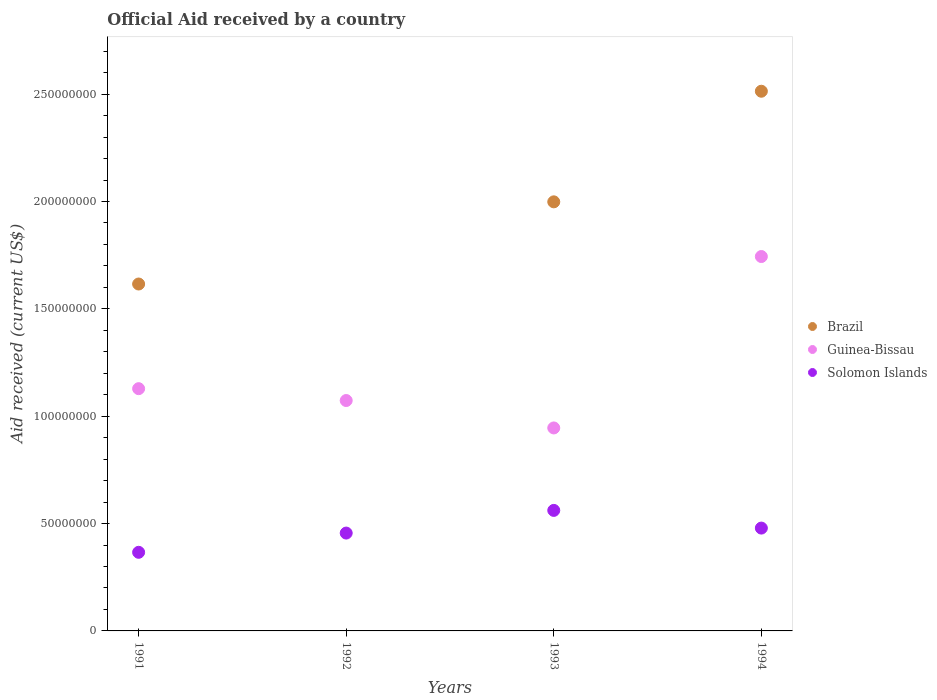Is the number of dotlines equal to the number of legend labels?
Your answer should be very brief. No. What is the net official aid received in Solomon Islands in 1992?
Your response must be concise. 4.56e+07. Across all years, what is the maximum net official aid received in Guinea-Bissau?
Provide a short and direct response. 1.74e+08. Across all years, what is the minimum net official aid received in Guinea-Bissau?
Your answer should be very brief. 9.45e+07. In which year was the net official aid received in Brazil maximum?
Offer a terse response. 1994. What is the total net official aid received in Brazil in the graph?
Give a very brief answer. 6.13e+08. What is the difference between the net official aid received in Guinea-Bissau in 1991 and that in 1993?
Your response must be concise. 1.83e+07. What is the difference between the net official aid received in Guinea-Bissau in 1993 and the net official aid received in Brazil in 1991?
Make the answer very short. -6.70e+07. What is the average net official aid received in Brazil per year?
Provide a succinct answer. 1.53e+08. In the year 1991, what is the difference between the net official aid received in Guinea-Bissau and net official aid received in Brazil?
Offer a very short reply. -4.87e+07. What is the ratio of the net official aid received in Guinea-Bissau in 1992 to that in 1994?
Provide a succinct answer. 0.62. Is the net official aid received in Solomon Islands in 1991 less than that in 1994?
Offer a very short reply. Yes. Is the difference between the net official aid received in Guinea-Bissau in 1991 and 1994 greater than the difference between the net official aid received in Brazil in 1991 and 1994?
Ensure brevity in your answer.  Yes. What is the difference between the highest and the second highest net official aid received in Solomon Islands?
Offer a very short reply. 8.24e+06. What is the difference between the highest and the lowest net official aid received in Guinea-Bissau?
Ensure brevity in your answer.  7.98e+07. In how many years, is the net official aid received in Guinea-Bissau greater than the average net official aid received in Guinea-Bissau taken over all years?
Offer a terse response. 1. Is the sum of the net official aid received in Solomon Islands in 1993 and 1994 greater than the maximum net official aid received in Guinea-Bissau across all years?
Offer a very short reply. No. Is it the case that in every year, the sum of the net official aid received in Solomon Islands and net official aid received in Brazil  is greater than the net official aid received in Guinea-Bissau?
Your answer should be very brief. No. Does the net official aid received in Solomon Islands monotonically increase over the years?
Provide a short and direct response. No. How many dotlines are there?
Keep it short and to the point. 3. How many years are there in the graph?
Ensure brevity in your answer.  4. What is the difference between two consecutive major ticks on the Y-axis?
Offer a very short reply. 5.00e+07. Are the values on the major ticks of Y-axis written in scientific E-notation?
Provide a succinct answer. No. Does the graph contain any zero values?
Make the answer very short. Yes. How many legend labels are there?
Provide a short and direct response. 3. How are the legend labels stacked?
Provide a short and direct response. Vertical. What is the title of the graph?
Your response must be concise. Official Aid received by a country. What is the label or title of the Y-axis?
Keep it short and to the point. Aid received (current US$). What is the Aid received (current US$) in Brazil in 1991?
Offer a very short reply. 1.62e+08. What is the Aid received (current US$) of Guinea-Bissau in 1991?
Your response must be concise. 1.13e+08. What is the Aid received (current US$) in Solomon Islands in 1991?
Provide a short and direct response. 3.66e+07. What is the Aid received (current US$) of Guinea-Bissau in 1992?
Your answer should be very brief. 1.07e+08. What is the Aid received (current US$) in Solomon Islands in 1992?
Your response must be concise. 4.56e+07. What is the Aid received (current US$) in Brazil in 1993?
Make the answer very short. 2.00e+08. What is the Aid received (current US$) of Guinea-Bissau in 1993?
Offer a very short reply. 9.45e+07. What is the Aid received (current US$) in Solomon Islands in 1993?
Ensure brevity in your answer.  5.61e+07. What is the Aid received (current US$) of Brazil in 1994?
Give a very brief answer. 2.51e+08. What is the Aid received (current US$) of Guinea-Bissau in 1994?
Make the answer very short. 1.74e+08. What is the Aid received (current US$) of Solomon Islands in 1994?
Your answer should be compact. 4.79e+07. Across all years, what is the maximum Aid received (current US$) in Brazil?
Offer a terse response. 2.51e+08. Across all years, what is the maximum Aid received (current US$) of Guinea-Bissau?
Ensure brevity in your answer.  1.74e+08. Across all years, what is the maximum Aid received (current US$) in Solomon Islands?
Provide a succinct answer. 5.61e+07. Across all years, what is the minimum Aid received (current US$) in Brazil?
Make the answer very short. 0. Across all years, what is the minimum Aid received (current US$) in Guinea-Bissau?
Offer a very short reply. 9.45e+07. Across all years, what is the minimum Aid received (current US$) in Solomon Islands?
Give a very brief answer. 3.66e+07. What is the total Aid received (current US$) of Brazil in the graph?
Your answer should be compact. 6.13e+08. What is the total Aid received (current US$) of Guinea-Bissau in the graph?
Give a very brief answer. 4.89e+08. What is the total Aid received (current US$) in Solomon Islands in the graph?
Provide a short and direct response. 1.86e+08. What is the difference between the Aid received (current US$) of Guinea-Bissau in 1991 and that in 1992?
Your response must be concise. 5.52e+06. What is the difference between the Aid received (current US$) of Solomon Islands in 1991 and that in 1992?
Your answer should be very brief. -8.96e+06. What is the difference between the Aid received (current US$) in Brazil in 1991 and that in 1993?
Offer a very short reply. -3.83e+07. What is the difference between the Aid received (current US$) in Guinea-Bissau in 1991 and that in 1993?
Your answer should be compact. 1.83e+07. What is the difference between the Aid received (current US$) of Solomon Islands in 1991 and that in 1993?
Give a very brief answer. -1.95e+07. What is the difference between the Aid received (current US$) of Brazil in 1991 and that in 1994?
Your answer should be compact. -8.98e+07. What is the difference between the Aid received (current US$) of Guinea-Bissau in 1991 and that in 1994?
Provide a succinct answer. -6.15e+07. What is the difference between the Aid received (current US$) in Solomon Islands in 1991 and that in 1994?
Offer a very short reply. -1.13e+07. What is the difference between the Aid received (current US$) of Guinea-Bissau in 1992 and that in 1993?
Ensure brevity in your answer.  1.28e+07. What is the difference between the Aid received (current US$) of Solomon Islands in 1992 and that in 1993?
Provide a short and direct response. -1.06e+07. What is the difference between the Aid received (current US$) of Guinea-Bissau in 1992 and that in 1994?
Offer a very short reply. -6.71e+07. What is the difference between the Aid received (current US$) in Solomon Islands in 1992 and that in 1994?
Make the answer very short. -2.32e+06. What is the difference between the Aid received (current US$) of Brazil in 1993 and that in 1994?
Your answer should be very brief. -5.15e+07. What is the difference between the Aid received (current US$) in Guinea-Bissau in 1993 and that in 1994?
Keep it short and to the point. -7.98e+07. What is the difference between the Aid received (current US$) in Solomon Islands in 1993 and that in 1994?
Keep it short and to the point. 8.24e+06. What is the difference between the Aid received (current US$) of Brazil in 1991 and the Aid received (current US$) of Guinea-Bissau in 1992?
Provide a short and direct response. 5.43e+07. What is the difference between the Aid received (current US$) in Brazil in 1991 and the Aid received (current US$) in Solomon Islands in 1992?
Offer a terse response. 1.16e+08. What is the difference between the Aid received (current US$) of Guinea-Bissau in 1991 and the Aid received (current US$) of Solomon Islands in 1992?
Offer a very short reply. 6.72e+07. What is the difference between the Aid received (current US$) in Brazil in 1991 and the Aid received (current US$) in Guinea-Bissau in 1993?
Ensure brevity in your answer.  6.70e+07. What is the difference between the Aid received (current US$) in Brazil in 1991 and the Aid received (current US$) in Solomon Islands in 1993?
Your response must be concise. 1.05e+08. What is the difference between the Aid received (current US$) of Guinea-Bissau in 1991 and the Aid received (current US$) of Solomon Islands in 1993?
Keep it short and to the point. 5.67e+07. What is the difference between the Aid received (current US$) in Brazil in 1991 and the Aid received (current US$) in Guinea-Bissau in 1994?
Provide a succinct answer. -1.28e+07. What is the difference between the Aid received (current US$) in Brazil in 1991 and the Aid received (current US$) in Solomon Islands in 1994?
Ensure brevity in your answer.  1.14e+08. What is the difference between the Aid received (current US$) of Guinea-Bissau in 1991 and the Aid received (current US$) of Solomon Islands in 1994?
Give a very brief answer. 6.49e+07. What is the difference between the Aid received (current US$) of Guinea-Bissau in 1992 and the Aid received (current US$) of Solomon Islands in 1993?
Ensure brevity in your answer.  5.12e+07. What is the difference between the Aid received (current US$) in Guinea-Bissau in 1992 and the Aid received (current US$) in Solomon Islands in 1994?
Your response must be concise. 5.94e+07. What is the difference between the Aid received (current US$) in Brazil in 1993 and the Aid received (current US$) in Guinea-Bissau in 1994?
Provide a succinct answer. 2.55e+07. What is the difference between the Aid received (current US$) in Brazil in 1993 and the Aid received (current US$) in Solomon Islands in 1994?
Your answer should be very brief. 1.52e+08. What is the difference between the Aid received (current US$) of Guinea-Bissau in 1993 and the Aid received (current US$) of Solomon Islands in 1994?
Ensure brevity in your answer.  4.66e+07. What is the average Aid received (current US$) of Brazil per year?
Offer a very short reply. 1.53e+08. What is the average Aid received (current US$) of Guinea-Bissau per year?
Offer a terse response. 1.22e+08. What is the average Aid received (current US$) in Solomon Islands per year?
Offer a very short reply. 4.66e+07. In the year 1991, what is the difference between the Aid received (current US$) of Brazil and Aid received (current US$) of Guinea-Bissau?
Keep it short and to the point. 4.87e+07. In the year 1991, what is the difference between the Aid received (current US$) of Brazil and Aid received (current US$) of Solomon Islands?
Ensure brevity in your answer.  1.25e+08. In the year 1991, what is the difference between the Aid received (current US$) of Guinea-Bissau and Aid received (current US$) of Solomon Islands?
Your answer should be compact. 7.62e+07. In the year 1992, what is the difference between the Aid received (current US$) of Guinea-Bissau and Aid received (current US$) of Solomon Islands?
Your response must be concise. 6.17e+07. In the year 1993, what is the difference between the Aid received (current US$) of Brazil and Aid received (current US$) of Guinea-Bissau?
Offer a terse response. 1.05e+08. In the year 1993, what is the difference between the Aid received (current US$) of Brazil and Aid received (current US$) of Solomon Islands?
Provide a short and direct response. 1.44e+08. In the year 1993, what is the difference between the Aid received (current US$) of Guinea-Bissau and Aid received (current US$) of Solomon Islands?
Keep it short and to the point. 3.84e+07. In the year 1994, what is the difference between the Aid received (current US$) in Brazil and Aid received (current US$) in Guinea-Bissau?
Make the answer very short. 7.70e+07. In the year 1994, what is the difference between the Aid received (current US$) in Brazil and Aid received (current US$) in Solomon Islands?
Provide a succinct answer. 2.03e+08. In the year 1994, what is the difference between the Aid received (current US$) of Guinea-Bissau and Aid received (current US$) of Solomon Islands?
Provide a short and direct response. 1.26e+08. What is the ratio of the Aid received (current US$) in Guinea-Bissau in 1991 to that in 1992?
Offer a terse response. 1.05. What is the ratio of the Aid received (current US$) in Solomon Islands in 1991 to that in 1992?
Provide a succinct answer. 0.8. What is the ratio of the Aid received (current US$) in Brazil in 1991 to that in 1993?
Provide a succinct answer. 0.81. What is the ratio of the Aid received (current US$) in Guinea-Bissau in 1991 to that in 1993?
Keep it short and to the point. 1.19. What is the ratio of the Aid received (current US$) in Solomon Islands in 1991 to that in 1993?
Keep it short and to the point. 0.65. What is the ratio of the Aid received (current US$) in Brazil in 1991 to that in 1994?
Make the answer very short. 0.64. What is the ratio of the Aid received (current US$) of Guinea-Bissau in 1991 to that in 1994?
Give a very brief answer. 0.65. What is the ratio of the Aid received (current US$) of Solomon Islands in 1991 to that in 1994?
Give a very brief answer. 0.76. What is the ratio of the Aid received (current US$) in Guinea-Bissau in 1992 to that in 1993?
Your response must be concise. 1.14. What is the ratio of the Aid received (current US$) in Solomon Islands in 1992 to that in 1993?
Your answer should be very brief. 0.81. What is the ratio of the Aid received (current US$) of Guinea-Bissau in 1992 to that in 1994?
Provide a succinct answer. 0.62. What is the ratio of the Aid received (current US$) of Solomon Islands in 1992 to that in 1994?
Ensure brevity in your answer.  0.95. What is the ratio of the Aid received (current US$) in Brazil in 1993 to that in 1994?
Give a very brief answer. 0.8. What is the ratio of the Aid received (current US$) in Guinea-Bissau in 1993 to that in 1994?
Offer a very short reply. 0.54. What is the ratio of the Aid received (current US$) in Solomon Islands in 1993 to that in 1994?
Ensure brevity in your answer.  1.17. What is the difference between the highest and the second highest Aid received (current US$) of Brazil?
Provide a short and direct response. 5.15e+07. What is the difference between the highest and the second highest Aid received (current US$) of Guinea-Bissau?
Offer a very short reply. 6.15e+07. What is the difference between the highest and the second highest Aid received (current US$) in Solomon Islands?
Offer a terse response. 8.24e+06. What is the difference between the highest and the lowest Aid received (current US$) in Brazil?
Offer a terse response. 2.51e+08. What is the difference between the highest and the lowest Aid received (current US$) in Guinea-Bissau?
Your answer should be compact. 7.98e+07. What is the difference between the highest and the lowest Aid received (current US$) in Solomon Islands?
Offer a very short reply. 1.95e+07. 